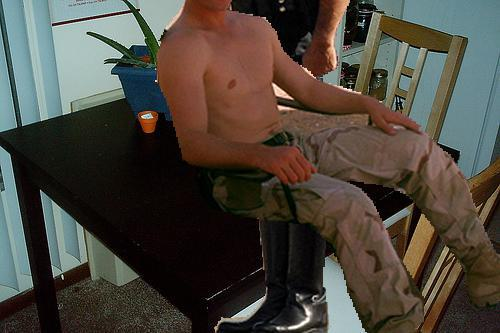What does the presence of the plant and candle indicate about the person's preferences? The inclusion of a plant and candle on the table likely indicates the person's preference for a touch of natural beauty and a tranquil ambiance in their living space. This choice reflects a desire to create a serene and pleasant environment, combining elements of nature and soft lighting. 